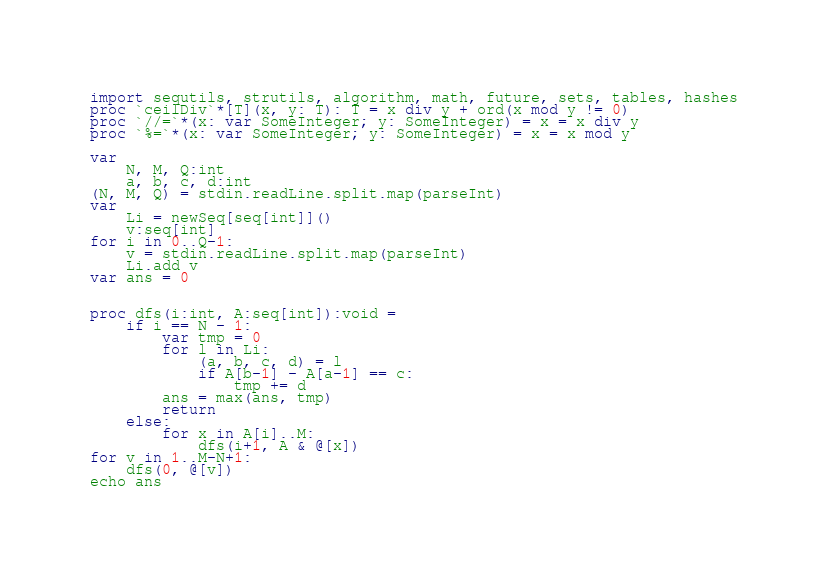Convert code to text. <code><loc_0><loc_0><loc_500><loc_500><_Nim_>import sequtils, strutils, algorithm, math, future, sets, tables, hashes
proc `ceilDiv`*[T](x, y: T): T = x div y + ord(x mod y != 0)
proc `//=`*(x: var SomeInteger; y: SomeInteger) = x = x div y
proc `%=`*(x: var SomeInteger; y: SomeInteger) = x = x mod y

var
    N, M, Q:int
    a, b, c, d:int
(N, M, Q) = stdin.readLine.split.map(parseInt)
var
    Li = newSeq[seq[int]]()
    v:seq[int]
for i in 0..Q-1:
    v = stdin.readLine.split.map(parseInt)
    Li.add v
var ans = 0 


proc dfs(i:int, A:seq[int]):void =
    if i == N - 1:
        var tmp = 0
        for l in Li:
            (a, b, c, d) = l
            if A[b-1] - A[a-1] == c:
                tmp += d
        ans = max(ans, tmp)
        return
    else:
        for x in A[i]..M:
            dfs(i+1, A & @[x])
for v in 1..M-N+1:
    dfs(0, @[v])
echo ans</code> 